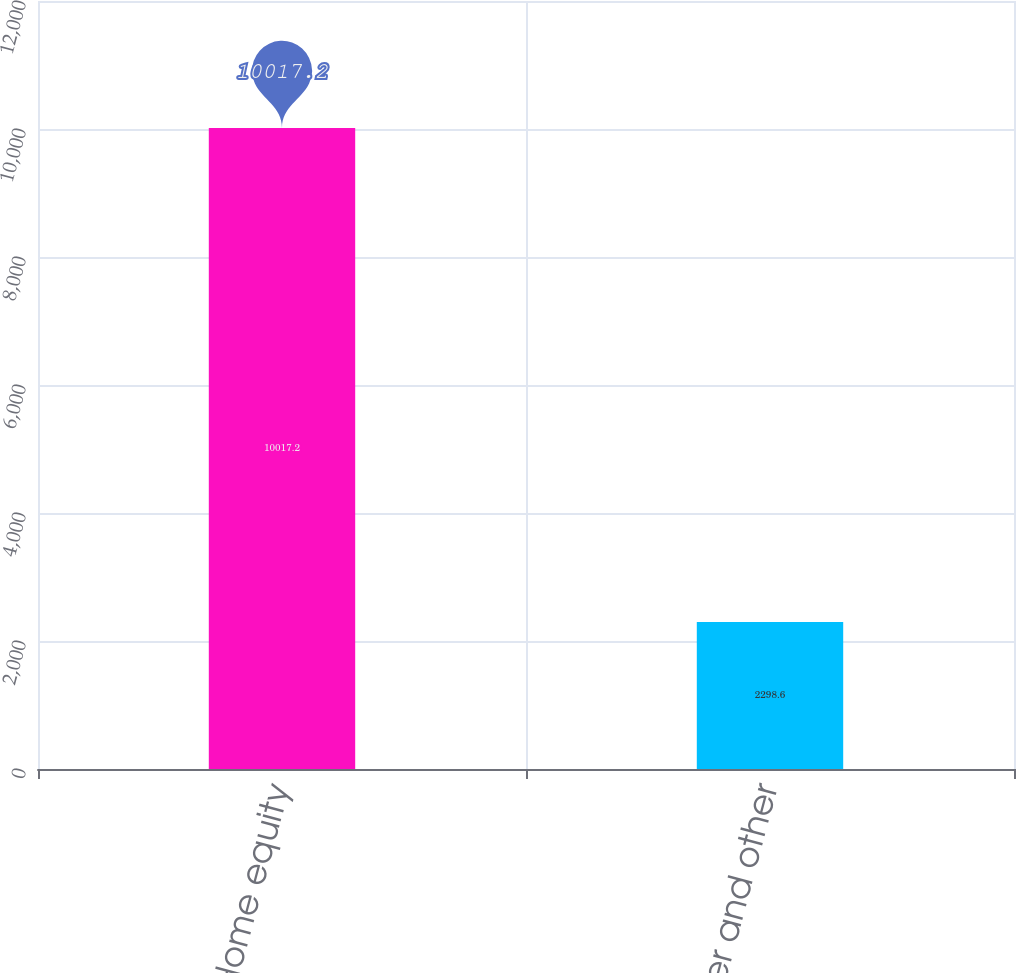Convert chart to OTSL. <chart><loc_0><loc_0><loc_500><loc_500><bar_chart><fcel>Home equity<fcel>Consumer and other<nl><fcel>10017.2<fcel>2298.6<nl></chart> 